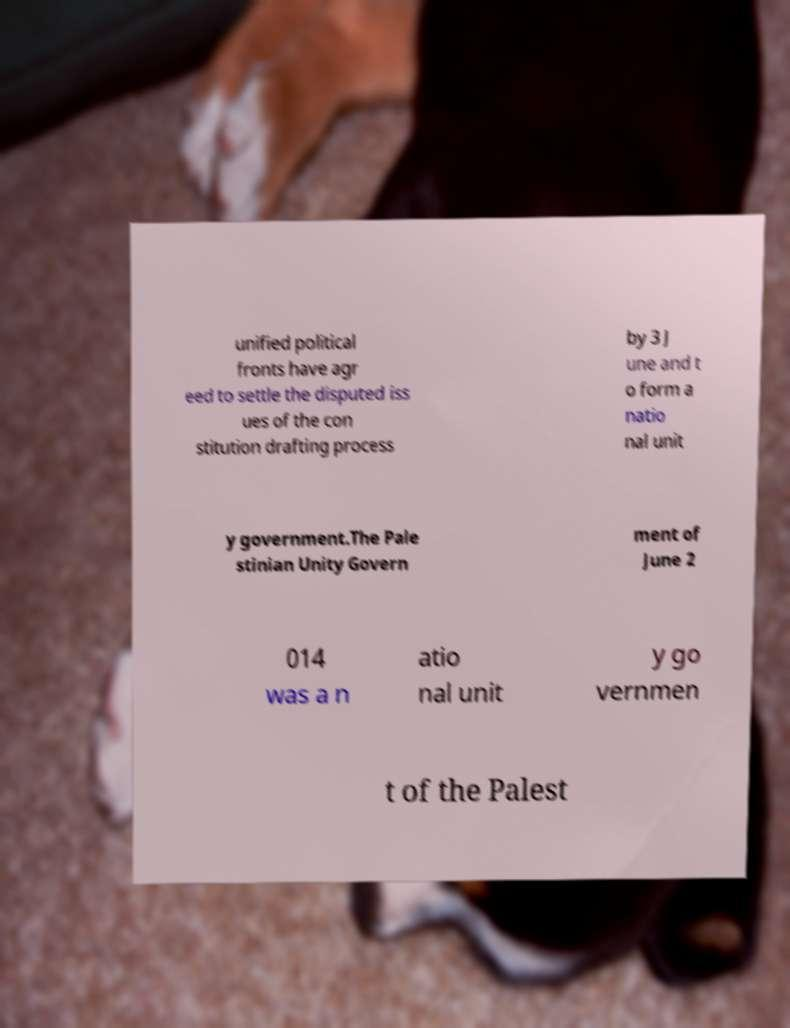Can you read and provide the text displayed in the image?This photo seems to have some interesting text. Can you extract and type it out for me? unified political fronts have agr eed to settle the disputed iss ues of the con stitution drafting process by 3 J une and t o form a natio nal unit y government.The Pale stinian Unity Govern ment of June 2 014 was a n atio nal unit y go vernmen t of the Palest 